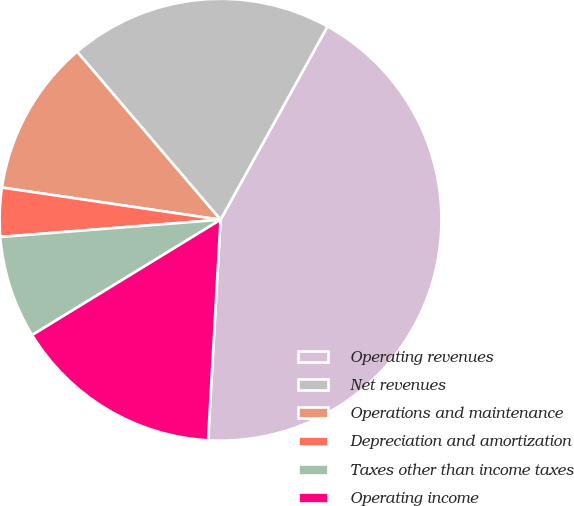<chart> <loc_0><loc_0><loc_500><loc_500><pie_chart><fcel>Operating revenues<fcel>Net revenues<fcel>Operations and maintenance<fcel>Depreciation and amortization<fcel>Taxes other than income taxes<fcel>Operating income<nl><fcel>42.86%<fcel>19.29%<fcel>11.43%<fcel>3.57%<fcel>7.5%<fcel>15.36%<nl></chart> 